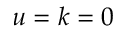Convert formula to latex. <formula><loc_0><loc_0><loc_500><loc_500>u = k = 0</formula> 